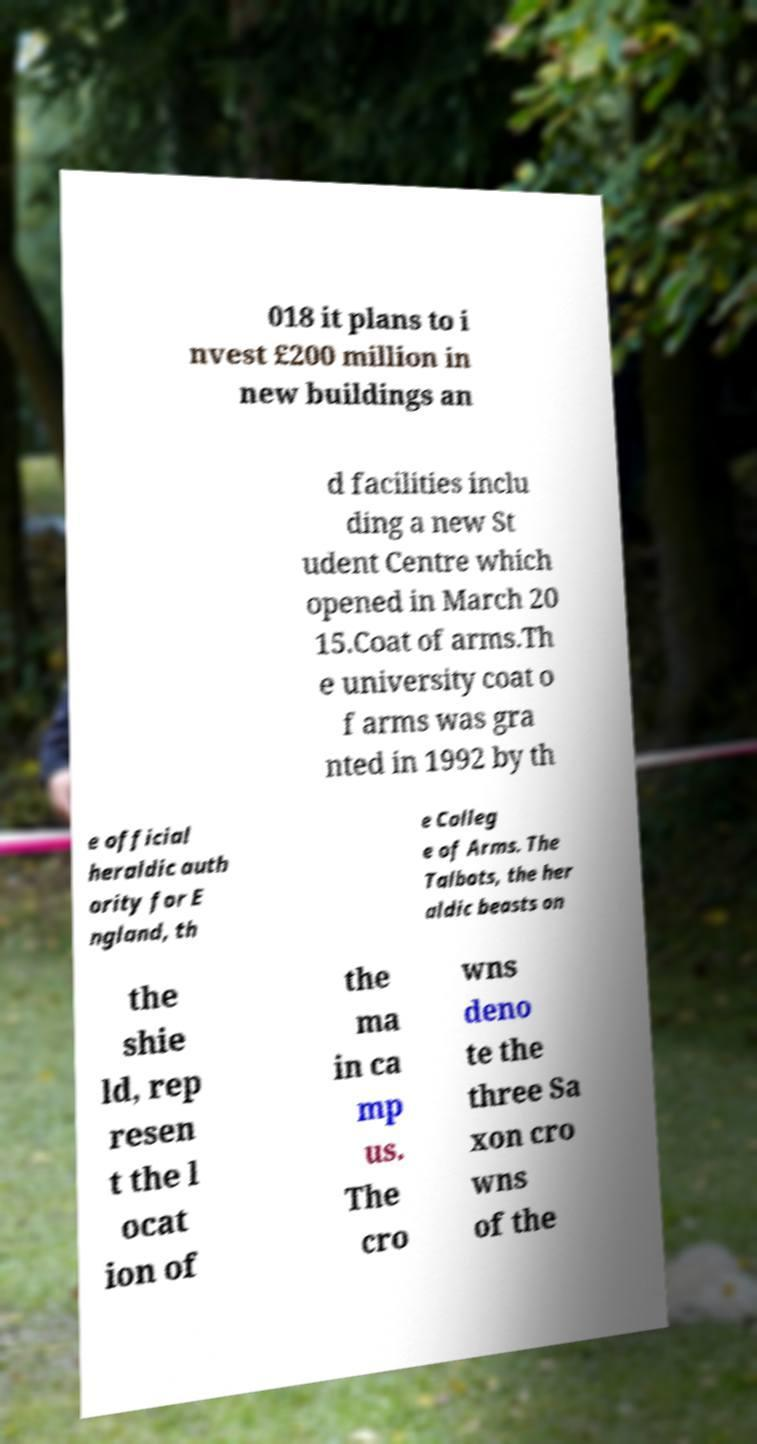I need the written content from this picture converted into text. Can you do that? 018 it plans to i nvest £200 million in new buildings an d facilities inclu ding a new St udent Centre which opened in March 20 15.Coat of arms.Th e university coat o f arms was gra nted in 1992 by th e official heraldic auth ority for E ngland, th e Colleg e of Arms. The Talbots, the her aldic beasts on the shie ld, rep resen t the l ocat ion of the ma in ca mp us. The cro wns deno te the three Sa xon cro wns of the 